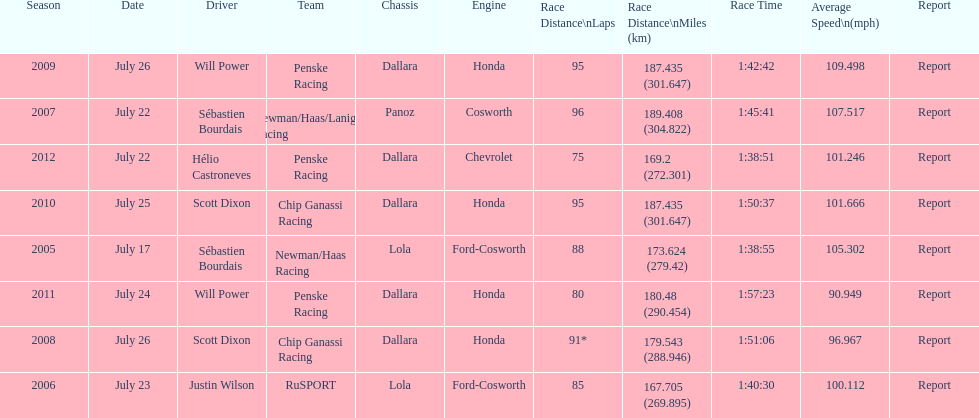How many flags other than france (the first flag) are represented? 3. 